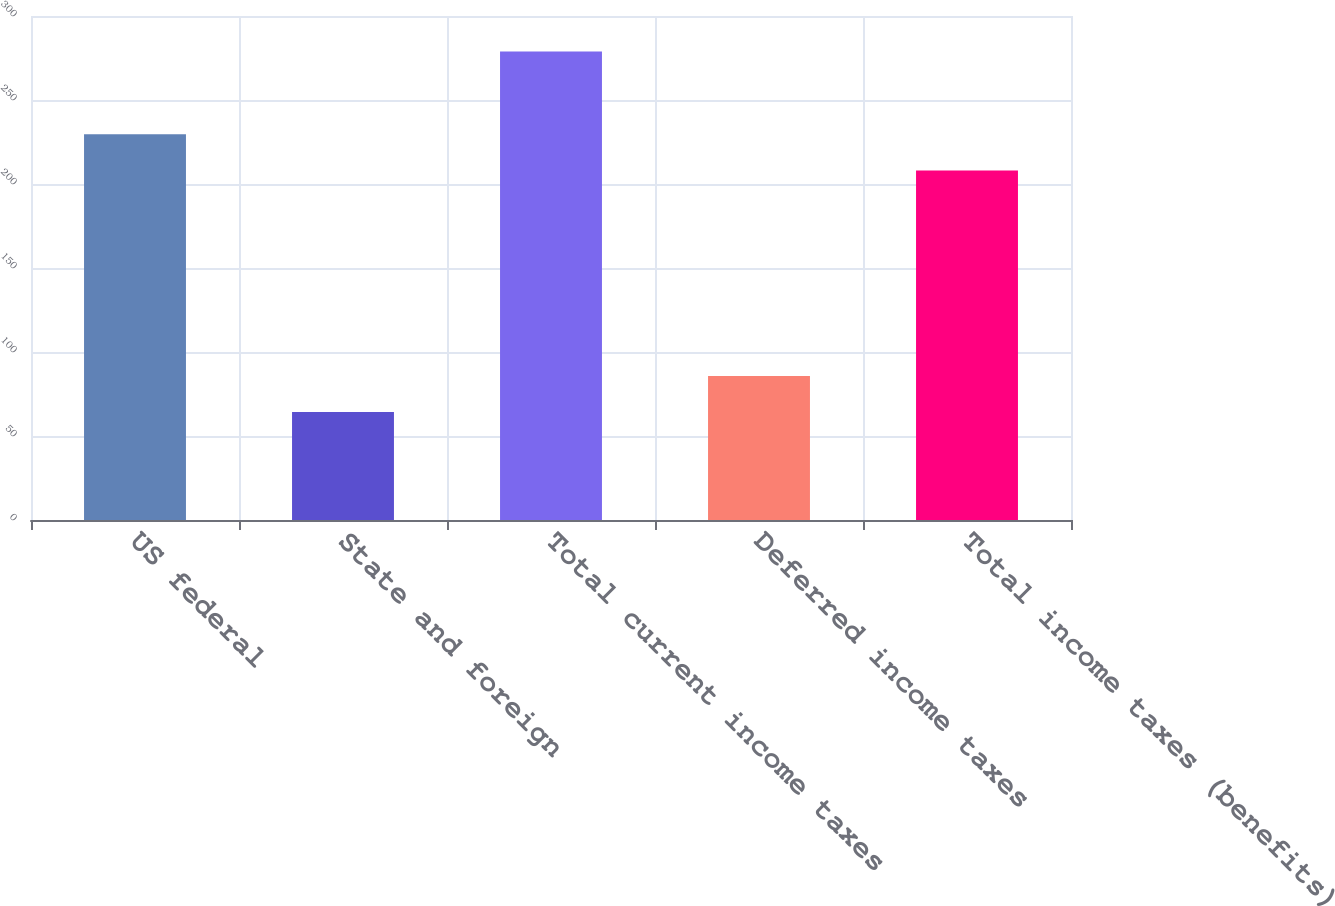Convert chart to OTSL. <chart><loc_0><loc_0><loc_500><loc_500><bar_chart><fcel>US federal<fcel>State and foreign<fcel>Total current income taxes<fcel>Deferred income taxes<fcel>Total income taxes (benefits)<nl><fcel>229.56<fcel>64.3<fcel>278.9<fcel>85.76<fcel>208.1<nl></chart> 